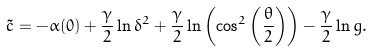Convert formula to latex. <formula><loc_0><loc_0><loc_500><loc_500>\tilde { c } = - \alpha ( 0 ) + \frac { \gamma } { 2 } \ln \delta ^ { 2 } + \frac { \gamma } { 2 } \ln \left ( \cos ^ { 2 } \left ( \frac { \theta } { 2 } \right ) \right ) - { \frac { \gamma } { 2 } } \ln g .</formula> 